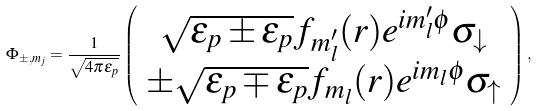<formula> <loc_0><loc_0><loc_500><loc_500>\Phi _ { \pm , m _ { j } } = \frac { 1 } { \sqrt { 4 \pi \varepsilon _ { p } } } \left ( \begin{array} { c } \sqrt { \varepsilon _ { p } \pm \epsilon _ { p } } f _ { m ^ { \prime } _ { l } } ( r ) e ^ { i m ^ { \prime } _ { l } \phi } \sigma _ { \downarrow } \\ \pm \sqrt { \varepsilon _ { p } \mp \epsilon _ { p } } f _ { m _ { l } } ( r ) e ^ { i m _ { l } \phi } \sigma _ { \uparrow } \\ \end{array} \right ) ,</formula> 